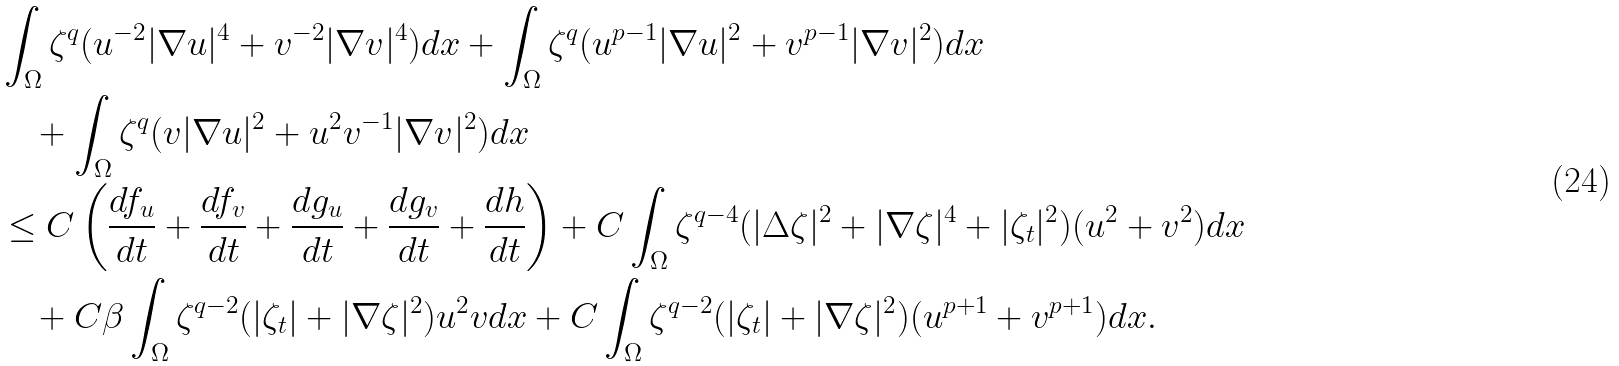Convert formula to latex. <formula><loc_0><loc_0><loc_500><loc_500>& \int _ { \Omega } \zeta ^ { q } ( u ^ { - 2 } | \nabla u | ^ { 4 } + v ^ { - 2 } | \nabla v | ^ { 4 } ) d x + \int _ { \Omega } \zeta ^ { q } ( u ^ { p - 1 } | \nabla u | ^ { 2 } + v ^ { p - 1 } | \nabla v | ^ { 2 } ) d x \\ & \quad + \int _ { \Omega } \zeta ^ { q } ( v | \nabla u | ^ { 2 } + u ^ { 2 } v ^ { - 1 } | \nabla v | ^ { 2 } ) d x \\ & \leq C \left ( \frac { d f _ { u } } { d t } + \frac { d f _ { v } } { d t } + \frac { d g _ { u } } { d t } + \frac { d g _ { v } } { d t } + \frac { d h } { d t } \right ) + C \int _ { \Omega } \zeta ^ { q - 4 } ( | \Delta \zeta | ^ { 2 } + | \nabla \zeta | ^ { 4 } + | \zeta _ { t } | ^ { 2 } ) ( u ^ { 2 } + v ^ { 2 } ) d x \\ & \quad + C \beta \int _ { \Omega } \zeta ^ { q - 2 } ( | \zeta _ { t } | + | \nabla \zeta | ^ { 2 } ) u ^ { 2 } v d x + C \int _ { \Omega } \zeta ^ { q - 2 } ( | \zeta _ { t } | + | \nabla \zeta | ^ { 2 } ) ( u ^ { p + 1 } + v ^ { p + 1 } ) d x .</formula> 